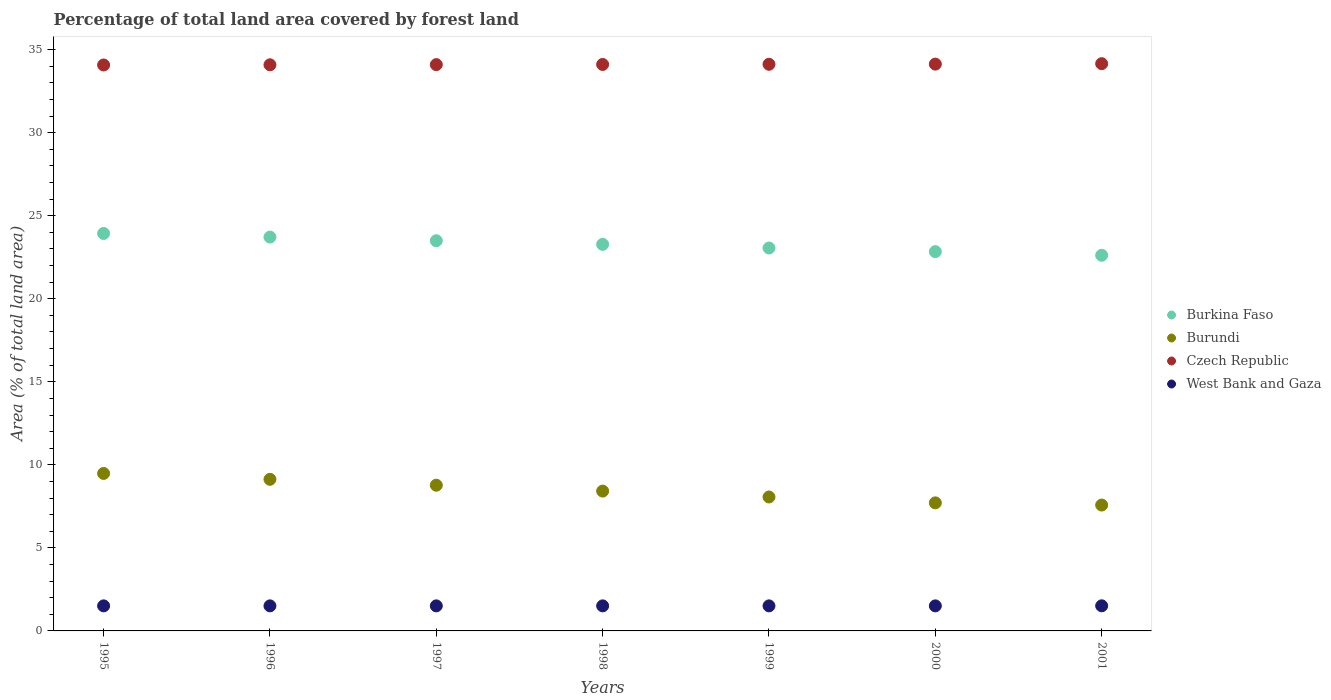How many different coloured dotlines are there?
Ensure brevity in your answer.  4. What is the percentage of forest land in Burundi in 1995?
Keep it short and to the point. 9.48. Across all years, what is the maximum percentage of forest land in Czech Republic?
Make the answer very short. 34.15. Across all years, what is the minimum percentage of forest land in West Bank and Gaza?
Provide a succinct answer. 1.51. In which year was the percentage of forest land in Burkina Faso maximum?
Your response must be concise. 1995. In which year was the percentage of forest land in Burundi minimum?
Keep it short and to the point. 2001. What is the total percentage of forest land in West Bank and Gaza in the graph?
Make the answer very short. 10.56. What is the difference between the percentage of forest land in Burundi in 1998 and that in 2001?
Provide a short and direct response. 0.84. What is the difference between the percentage of forest land in Burundi in 1997 and the percentage of forest land in Czech Republic in 1996?
Offer a terse response. -25.31. What is the average percentage of forest land in Burundi per year?
Offer a very short reply. 8.45. In the year 2000, what is the difference between the percentage of forest land in Burkina Faso and percentage of forest land in Czech Republic?
Keep it short and to the point. -11.29. What is the ratio of the percentage of forest land in Burkina Faso in 1999 to that in 2000?
Provide a short and direct response. 1.01. What is the difference between the highest and the second highest percentage of forest land in Burundi?
Offer a very short reply. 0.35. What is the difference between the highest and the lowest percentage of forest land in Burundi?
Keep it short and to the point. 1.9. Is the percentage of forest land in Burundi strictly greater than the percentage of forest land in Czech Republic over the years?
Give a very brief answer. No. Is the percentage of forest land in Burkina Faso strictly less than the percentage of forest land in West Bank and Gaza over the years?
Your answer should be very brief. No. How many dotlines are there?
Your answer should be compact. 4. How many years are there in the graph?
Provide a short and direct response. 7. Where does the legend appear in the graph?
Provide a succinct answer. Center right. How are the legend labels stacked?
Offer a terse response. Vertical. What is the title of the graph?
Provide a short and direct response. Percentage of total land area covered by forest land. What is the label or title of the X-axis?
Your answer should be compact. Years. What is the label or title of the Y-axis?
Your answer should be compact. Area (% of total land area). What is the Area (% of total land area) in Burkina Faso in 1995?
Give a very brief answer. 23.93. What is the Area (% of total land area) of Burundi in 1995?
Provide a succinct answer. 9.48. What is the Area (% of total land area) in Czech Republic in 1995?
Provide a short and direct response. 34.08. What is the Area (% of total land area) of West Bank and Gaza in 1995?
Offer a very short reply. 1.51. What is the Area (% of total land area) in Burkina Faso in 1996?
Keep it short and to the point. 23.71. What is the Area (% of total land area) of Burundi in 1996?
Your response must be concise. 9.13. What is the Area (% of total land area) of Czech Republic in 1996?
Offer a very short reply. 34.09. What is the Area (% of total land area) in West Bank and Gaza in 1996?
Make the answer very short. 1.51. What is the Area (% of total land area) of Burkina Faso in 1997?
Ensure brevity in your answer.  23.49. What is the Area (% of total land area) of Burundi in 1997?
Your answer should be compact. 8.77. What is the Area (% of total land area) of Czech Republic in 1997?
Give a very brief answer. 34.1. What is the Area (% of total land area) of West Bank and Gaza in 1997?
Provide a succinct answer. 1.51. What is the Area (% of total land area) in Burkina Faso in 1998?
Your answer should be very brief. 23.27. What is the Area (% of total land area) in Burundi in 1998?
Offer a terse response. 8.42. What is the Area (% of total land area) of Czech Republic in 1998?
Keep it short and to the point. 34.11. What is the Area (% of total land area) in West Bank and Gaza in 1998?
Your answer should be very brief. 1.51. What is the Area (% of total land area) of Burkina Faso in 1999?
Your response must be concise. 23.06. What is the Area (% of total land area) of Burundi in 1999?
Give a very brief answer. 8.06. What is the Area (% of total land area) of Czech Republic in 1999?
Offer a very short reply. 34.12. What is the Area (% of total land area) in West Bank and Gaza in 1999?
Your response must be concise. 1.51. What is the Area (% of total land area) in Burkina Faso in 2000?
Your answer should be compact. 22.84. What is the Area (% of total land area) in Burundi in 2000?
Your response must be concise. 7.71. What is the Area (% of total land area) in Czech Republic in 2000?
Keep it short and to the point. 34.13. What is the Area (% of total land area) of West Bank and Gaza in 2000?
Give a very brief answer. 1.51. What is the Area (% of total land area) of Burkina Faso in 2001?
Give a very brief answer. 22.62. What is the Area (% of total land area) in Burundi in 2001?
Offer a terse response. 7.58. What is the Area (% of total land area) of Czech Republic in 2001?
Your answer should be compact. 34.15. What is the Area (% of total land area) of West Bank and Gaza in 2001?
Give a very brief answer. 1.51. Across all years, what is the maximum Area (% of total land area) of Burkina Faso?
Make the answer very short. 23.93. Across all years, what is the maximum Area (% of total land area) of Burundi?
Your response must be concise. 9.48. Across all years, what is the maximum Area (% of total land area) of Czech Republic?
Give a very brief answer. 34.15. Across all years, what is the maximum Area (% of total land area) in West Bank and Gaza?
Your response must be concise. 1.51. Across all years, what is the minimum Area (% of total land area) of Burkina Faso?
Offer a terse response. 22.62. Across all years, what is the minimum Area (% of total land area) in Burundi?
Provide a succinct answer. 7.58. Across all years, what is the minimum Area (% of total land area) in Czech Republic?
Ensure brevity in your answer.  34.08. Across all years, what is the minimum Area (% of total land area) in West Bank and Gaza?
Offer a terse response. 1.51. What is the total Area (% of total land area) of Burkina Faso in the graph?
Offer a very short reply. 162.92. What is the total Area (% of total land area) in Burundi in the graph?
Make the answer very short. 59.16. What is the total Area (% of total land area) of Czech Republic in the graph?
Offer a very short reply. 238.76. What is the total Area (% of total land area) of West Bank and Gaza in the graph?
Offer a very short reply. 10.56. What is the difference between the Area (% of total land area) in Burkina Faso in 1995 and that in 1996?
Your response must be concise. 0.22. What is the difference between the Area (% of total land area) in Burundi in 1995 and that in 1996?
Give a very brief answer. 0.35. What is the difference between the Area (% of total land area) of Czech Republic in 1995 and that in 1996?
Make the answer very short. -0.01. What is the difference between the Area (% of total land area) of Burkina Faso in 1995 and that in 1997?
Offer a very short reply. 0.44. What is the difference between the Area (% of total land area) in Burundi in 1995 and that in 1997?
Your response must be concise. 0.71. What is the difference between the Area (% of total land area) in Czech Republic in 1995 and that in 1997?
Your answer should be compact. -0.02. What is the difference between the Area (% of total land area) of Burkina Faso in 1995 and that in 1998?
Provide a short and direct response. 0.66. What is the difference between the Area (% of total land area) of Burundi in 1995 and that in 1998?
Your answer should be compact. 1.06. What is the difference between the Area (% of total land area) in Czech Republic in 1995 and that in 1998?
Keep it short and to the point. -0.03. What is the difference between the Area (% of total land area) in Burkina Faso in 1995 and that in 1999?
Offer a very short reply. 0.88. What is the difference between the Area (% of total land area) of Burundi in 1995 and that in 1999?
Offer a very short reply. 1.42. What is the difference between the Area (% of total land area) in Czech Republic in 1995 and that in 1999?
Offer a very short reply. -0.04. What is the difference between the Area (% of total land area) in West Bank and Gaza in 1995 and that in 1999?
Your answer should be very brief. 0. What is the difference between the Area (% of total land area) of Burkina Faso in 1995 and that in 2000?
Offer a very short reply. 1.09. What is the difference between the Area (% of total land area) of Burundi in 1995 and that in 2000?
Give a very brief answer. 1.77. What is the difference between the Area (% of total land area) of Czech Republic in 1995 and that in 2000?
Offer a very short reply. -0.05. What is the difference between the Area (% of total land area) in West Bank and Gaza in 1995 and that in 2000?
Offer a terse response. 0. What is the difference between the Area (% of total land area) of Burkina Faso in 1995 and that in 2001?
Offer a very short reply. 1.31. What is the difference between the Area (% of total land area) in Burundi in 1995 and that in 2001?
Ensure brevity in your answer.  1.9. What is the difference between the Area (% of total land area) of Czech Republic in 1995 and that in 2001?
Your answer should be very brief. -0.08. What is the difference between the Area (% of total land area) in West Bank and Gaza in 1995 and that in 2001?
Keep it short and to the point. -0. What is the difference between the Area (% of total land area) in Burkina Faso in 1996 and that in 1997?
Your answer should be very brief. 0.22. What is the difference between the Area (% of total land area) of Burundi in 1996 and that in 1997?
Provide a short and direct response. 0.35. What is the difference between the Area (% of total land area) in Czech Republic in 1996 and that in 1997?
Make the answer very short. -0.01. What is the difference between the Area (% of total land area) in Burkina Faso in 1996 and that in 1998?
Offer a very short reply. 0.44. What is the difference between the Area (% of total land area) in Burundi in 1996 and that in 1998?
Provide a short and direct response. 0.71. What is the difference between the Area (% of total land area) of Czech Republic in 1996 and that in 1998?
Your answer should be very brief. -0.02. What is the difference between the Area (% of total land area) of West Bank and Gaza in 1996 and that in 1998?
Provide a short and direct response. 0. What is the difference between the Area (% of total land area) in Burkina Faso in 1996 and that in 1999?
Offer a terse response. 0.66. What is the difference between the Area (% of total land area) of Burundi in 1996 and that in 1999?
Offer a terse response. 1.06. What is the difference between the Area (% of total land area) in Czech Republic in 1996 and that in 1999?
Give a very brief answer. -0.03. What is the difference between the Area (% of total land area) in Burkina Faso in 1996 and that in 2000?
Make the answer very short. 0.88. What is the difference between the Area (% of total land area) in Burundi in 1996 and that in 2000?
Your answer should be very brief. 1.42. What is the difference between the Area (% of total land area) of Czech Republic in 1996 and that in 2000?
Make the answer very short. -0.04. What is the difference between the Area (% of total land area) of West Bank and Gaza in 1996 and that in 2000?
Your answer should be very brief. 0. What is the difference between the Area (% of total land area) of Burkina Faso in 1996 and that in 2001?
Offer a very short reply. 1.09. What is the difference between the Area (% of total land area) in Burundi in 1996 and that in 2001?
Provide a succinct answer. 1.55. What is the difference between the Area (% of total land area) in Czech Republic in 1996 and that in 2001?
Your answer should be compact. -0.07. What is the difference between the Area (% of total land area) in West Bank and Gaza in 1996 and that in 2001?
Your answer should be very brief. -0. What is the difference between the Area (% of total land area) in Burkina Faso in 1997 and that in 1998?
Make the answer very short. 0.22. What is the difference between the Area (% of total land area) in Burundi in 1997 and that in 1998?
Ensure brevity in your answer.  0.35. What is the difference between the Area (% of total land area) of Czech Republic in 1997 and that in 1998?
Offer a very short reply. -0.01. What is the difference between the Area (% of total land area) in Burkina Faso in 1997 and that in 1999?
Your answer should be compact. 0.44. What is the difference between the Area (% of total land area) in Burundi in 1997 and that in 1999?
Keep it short and to the point. 0.71. What is the difference between the Area (% of total land area) of Czech Republic in 1997 and that in 1999?
Offer a terse response. -0.02. What is the difference between the Area (% of total land area) of Burkina Faso in 1997 and that in 2000?
Your response must be concise. 0.66. What is the difference between the Area (% of total land area) in Burundi in 1997 and that in 2000?
Make the answer very short. 1.06. What is the difference between the Area (% of total land area) in Czech Republic in 1997 and that in 2000?
Your answer should be very brief. -0.03. What is the difference between the Area (% of total land area) in West Bank and Gaza in 1997 and that in 2000?
Offer a very short reply. 0. What is the difference between the Area (% of total land area) in Burkina Faso in 1997 and that in 2001?
Ensure brevity in your answer.  0.88. What is the difference between the Area (% of total land area) in Burundi in 1997 and that in 2001?
Your answer should be very brief. 1.2. What is the difference between the Area (% of total land area) in Czech Republic in 1997 and that in 2001?
Ensure brevity in your answer.  -0.06. What is the difference between the Area (% of total land area) of West Bank and Gaza in 1997 and that in 2001?
Your response must be concise. -0. What is the difference between the Area (% of total land area) of Burkina Faso in 1998 and that in 1999?
Ensure brevity in your answer.  0.22. What is the difference between the Area (% of total land area) of Burundi in 1998 and that in 1999?
Make the answer very short. 0.35. What is the difference between the Area (% of total land area) in Czech Republic in 1998 and that in 1999?
Offer a very short reply. -0.01. What is the difference between the Area (% of total land area) in West Bank and Gaza in 1998 and that in 1999?
Provide a short and direct response. 0. What is the difference between the Area (% of total land area) of Burkina Faso in 1998 and that in 2000?
Make the answer very short. 0.44. What is the difference between the Area (% of total land area) in Burundi in 1998 and that in 2000?
Offer a terse response. 0.71. What is the difference between the Area (% of total land area) in Czech Republic in 1998 and that in 2000?
Give a very brief answer. -0.02. What is the difference between the Area (% of total land area) in West Bank and Gaza in 1998 and that in 2000?
Provide a short and direct response. 0. What is the difference between the Area (% of total land area) in Burkina Faso in 1998 and that in 2001?
Keep it short and to the point. 0.66. What is the difference between the Area (% of total land area) of Burundi in 1998 and that in 2001?
Your response must be concise. 0.84. What is the difference between the Area (% of total land area) in Czech Republic in 1998 and that in 2001?
Offer a terse response. -0.05. What is the difference between the Area (% of total land area) of West Bank and Gaza in 1998 and that in 2001?
Provide a short and direct response. -0. What is the difference between the Area (% of total land area) in Burkina Faso in 1999 and that in 2000?
Provide a short and direct response. 0.22. What is the difference between the Area (% of total land area) of Burundi in 1999 and that in 2000?
Keep it short and to the point. 0.35. What is the difference between the Area (% of total land area) in Czech Republic in 1999 and that in 2000?
Your response must be concise. -0.01. What is the difference between the Area (% of total land area) in West Bank and Gaza in 1999 and that in 2000?
Give a very brief answer. 0. What is the difference between the Area (% of total land area) of Burkina Faso in 1999 and that in 2001?
Ensure brevity in your answer.  0.44. What is the difference between the Area (% of total land area) of Burundi in 1999 and that in 2001?
Keep it short and to the point. 0.49. What is the difference between the Area (% of total land area) in Czech Republic in 1999 and that in 2001?
Offer a terse response. -0.04. What is the difference between the Area (% of total land area) in West Bank and Gaza in 1999 and that in 2001?
Ensure brevity in your answer.  -0. What is the difference between the Area (% of total land area) in Burkina Faso in 2000 and that in 2001?
Provide a succinct answer. 0.22. What is the difference between the Area (% of total land area) in Burundi in 2000 and that in 2001?
Make the answer very short. 0.13. What is the difference between the Area (% of total land area) of Czech Republic in 2000 and that in 2001?
Keep it short and to the point. -0.03. What is the difference between the Area (% of total land area) of West Bank and Gaza in 2000 and that in 2001?
Offer a very short reply. -0. What is the difference between the Area (% of total land area) of Burkina Faso in 1995 and the Area (% of total land area) of Burundi in 1996?
Your answer should be very brief. 14.8. What is the difference between the Area (% of total land area) in Burkina Faso in 1995 and the Area (% of total land area) in Czech Republic in 1996?
Provide a succinct answer. -10.15. What is the difference between the Area (% of total land area) in Burkina Faso in 1995 and the Area (% of total land area) in West Bank and Gaza in 1996?
Offer a terse response. 22.42. What is the difference between the Area (% of total land area) in Burundi in 1995 and the Area (% of total land area) in Czech Republic in 1996?
Offer a very short reply. -24.6. What is the difference between the Area (% of total land area) in Burundi in 1995 and the Area (% of total land area) in West Bank and Gaza in 1996?
Your answer should be very brief. 7.97. What is the difference between the Area (% of total land area) in Czech Republic in 1995 and the Area (% of total land area) in West Bank and Gaza in 1996?
Ensure brevity in your answer.  32.57. What is the difference between the Area (% of total land area) of Burkina Faso in 1995 and the Area (% of total land area) of Burundi in 1997?
Keep it short and to the point. 15.16. What is the difference between the Area (% of total land area) of Burkina Faso in 1995 and the Area (% of total land area) of Czech Republic in 1997?
Ensure brevity in your answer.  -10.17. What is the difference between the Area (% of total land area) in Burkina Faso in 1995 and the Area (% of total land area) in West Bank and Gaza in 1997?
Give a very brief answer. 22.42. What is the difference between the Area (% of total land area) of Burundi in 1995 and the Area (% of total land area) of Czech Republic in 1997?
Make the answer very short. -24.61. What is the difference between the Area (% of total land area) in Burundi in 1995 and the Area (% of total land area) in West Bank and Gaza in 1997?
Provide a short and direct response. 7.97. What is the difference between the Area (% of total land area) of Czech Republic in 1995 and the Area (% of total land area) of West Bank and Gaza in 1997?
Offer a very short reply. 32.57. What is the difference between the Area (% of total land area) of Burkina Faso in 1995 and the Area (% of total land area) of Burundi in 1998?
Your answer should be very brief. 15.51. What is the difference between the Area (% of total land area) of Burkina Faso in 1995 and the Area (% of total land area) of Czech Republic in 1998?
Give a very brief answer. -10.18. What is the difference between the Area (% of total land area) of Burkina Faso in 1995 and the Area (% of total land area) of West Bank and Gaza in 1998?
Your answer should be very brief. 22.42. What is the difference between the Area (% of total land area) of Burundi in 1995 and the Area (% of total land area) of Czech Republic in 1998?
Offer a terse response. -24.62. What is the difference between the Area (% of total land area) in Burundi in 1995 and the Area (% of total land area) in West Bank and Gaza in 1998?
Provide a succinct answer. 7.97. What is the difference between the Area (% of total land area) in Czech Republic in 1995 and the Area (% of total land area) in West Bank and Gaza in 1998?
Give a very brief answer. 32.57. What is the difference between the Area (% of total land area) of Burkina Faso in 1995 and the Area (% of total land area) of Burundi in 1999?
Keep it short and to the point. 15.87. What is the difference between the Area (% of total land area) of Burkina Faso in 1995 and the Area (% of total land area) of Czech Republic in 1999?
Give a very brief answer. -10.19. What is the difference between the Area (% of total land area) in Burkina Faso in 1995 and the Area (% of total land area) in West Bank and Gaza in 1999?
Keep it short and to the point. 22.42. What is the difference between the Area (% of total land area) in Burundi in 1995 and the Area (% of total land area) in Czech Republic in 1999?
Keep it short and to the point. -24.63. What is the difference between the Area (% of total land area) in Burundi in 1995 and the Area (% of total land area) in West Bank and Gaza in 1999?
Make the answer very short. 7.97. What is the difference between the Area (% of total land area) in Czech Republic in 1995 and the Area (% of total land area) in West Bank and Gaza in 1999?
Your answer should be compact. 32.57. What is the difference between the Area (% of total land area) in Burkina Faso in 1995 and the Area (% of total land area) in Burundi in 2000?
Keep it short and to the point. 16.22. What is the difference between the Area (% of total land area) of Burkina Faso in 1995 and the Area (% of total land area) of Czech Republic in 2000?
Keep it short and to the point. -10.2. What is the difference between the Area (% of total land area) of Burkina Faso in 1995 and the Area (% of total land area) of West Bank and Gaza in 2000?
Your response must be concise. 22.42. What is the difference between the Area (% of total land area) in Burundi in 1995 and the Area (% of total land area) in Czech Republic in 2000?
Keep it short and to the point. -24.64. What is the difference between the Area (% of total land area) in Burundi in 1995 and the Area (% of total land area) in West Bank and Gaza in 2000?
Offer a terse response. 7.97. What is the difference between the Area (% of total land area) in Czech Republic in 1995 and the Area (% of total land area) in West Bank and Gaza in 2000?
Offer a terse response. 32.57. What is the difference between the Area (% of total land area) in Burkina Faso in 1995 and the Area (% of total land area) in Burundi in 2001?
Your response must be concise. 16.35. What is the difference between the Area (% of total land area) of Burkina Faso in 1995 and the Area (% of total land area) of Czech Republic in 2001?
Give a very brief answer. -10.22. What is the difference between the Area (% of total land area) of Burkina Faso in 1995 and the Area (% of total land area) of West Bank and Gaza in 2001?
Your answer should be very brief. 22.42. What is the difference between the Area (% of total land area) of Burundi in 1995 and the Area (% of total land area) of Czech Republic in 2001?
Provide a succinct answer. -24.67. What is the difference between the Area (% of total land area) in Burundi in 1995 and the Area (% of total land area) in West Bank and Gaza in 2001?
Your response must be concise. 7.97. What is the difference between the Area (% of total land area) of Czech Republic in 1995 and the Area (% of total land area) of West Bank and Gaza in 2001?
Offer a terse response. 32.56. What is the difference between the Area (% of total land area) in Burkina Faso in 1996 and the Area (% of total land area) in Burundi in 1997?
Offer a very short reply. 14.94. What is the difference between the Area (% of total land area) of Burkina Faso in 1996 and the Area (% of total land area) of Czech Republic in 1997?
Give a very brief answer. -10.38. What is the difference between the Area (% of total land area) in Burkina Faso in 1996 and the Area (% of total land area) in West Bank and Gaza in 1997?
Provide a short and direct response. 22.2. What is the difference between the Area (% of total land area) in Burundi in 1996 and the Area (% of total land area) in Czech Republic in 1997?
Provide a succinct answer. -24.97. What is the difference between the Area (% of total land area) in Burundi in 1996 and the Area (% of total land area) in West Bank and Gaza in 1997?
Give a very brief answer. 7.62. What is the difference between the Area (% of total land area) in Czech Republic in 1996 and the Area (% of total land area) in West Bank and Gaza in 1997?
Provide a short and direct response. 32.58. What is the difference between the Area (% of total land area) in Burkina Faso in 1996 and the Area (% of total land area) in Burundi in 1998?
Your answer should be very brief. 15.29. What is the difference between the Area (% of total land area) in Burkina Faso in 1996 and the Area (% of total land area) in Czech Republic in 1998?
Offer a terse response. -10.39. What is the difference between the Area (% of total land area) of Burkina Faso in 1996 and the Area (% of total land area) of West Bank and Gaza in 1998?
Give a very brief answer. 22.2. What is the difference between the Area (% of total land area) in Burundi in 1996 and the Area (% of total land area) in Czech Republic in 1998?
Ensure brevity in your answer.  -24.98. What is the difference between the Area (% of total land area) of Burundi in 1996 and the Area (% of total land area) of West Bank and Gaza in 1998?
Give a very brief answer. 7.62. What is the difference between the Area (% of total land area) of Czech Republic in 1996 and the Area (% of total land area) of West Bank and Gaza in 1998?
Provide a short and direct response. 32.58. What is the difference between the Area (% of total land area) of Burkina Faso in 1996 and the Area (% of total land area) of Burundi in 1999?
Offer a very short reply. 15.65. What is the difference between the Area (% of total land area) in Burkina Faso in 1996 and the Area (% of total land area) in Czech Republic in 1999?
Offer a very short reply. -10.4. What is the difference between the Area (% of total land area) of Burkina Faso in 1996 and the Area (% of total land area) of West Bank and Gaza in 1999?
Offer a terse response. 22.2. What is the difference between the Area (% of total land area) in Burundi in 1996 and the Area (% of total land area) in Czech Republic in 1999?
Keep it short and to the point. -24.99. What is the difference between the Area (% of total land area) of Burundi in 1996 and the Area (% of total land area) of West Bank and Gaza in 1999?
Provide a succinct answer. 7.62. What is the difference between the Area (% of total land area) in Czech Republic in 1996 and the Area (% of total land area) in West Bank and Gaza in 1999?
Keep it short and to the point. 32.58. What is the difference between the Area (% of total land area) in Burkina Faso in 1996 and the Area (% of total land area) in Burundi in 2000?
Provide a succinct answer. 16. What is the difference between the Area (% of total land area) in Burkina Faso in 1996 and the Area (% of total land area) in Czech Republic in 2000?
Provide a succinct answer. -10.42. What is the difference between the Area (% of total land area) in Burkina Faso in 1996 and the Area (% of total land area) in West Bank and Gaza in 2000?
Your answer should be very brief. 22.2. What is the difference between the Area (% of total land area) in Burundi in 1996 and the Area (% of total land area) in Czech Republic in 2000?
Offer a very short reply. -25. What is the difference between the Area (% of total land area) of Burundi in 1996 and the Area (% of total land area) of West Bank and Gaza in 2000?
Keep it short and to the point. 7.62. What is the difference between the Area (% of total land area) in Czech Republic in 1996 and the Area (% of total land area) in West Bank and Gaza in 2000?
Provide a short and direct response. 32.58. What is the difference between the Area (% of total land area) in Burkina Faso in 1996 and the Area (% of total land area) in Burundi in 2001?
Offer a terse response. 16.13. What is the difference between the Area (% of total land area) of Burkina Faso in 1996 and the Area (% of total land area) of Czech Republic in 2001?
Give a very brief answer. -10.44. What is the difference between the Area (% of total land area) of Burkina Faso in 1996 and the Area (% of total land area) of West Bank and Gaza in 2001?
Your answer should be compact. 22.2. What is the difference between the Area (% of total land area) of Burundi in 1996 and the Area (% of total land area) of Czech Republic in 2001?
Offer a terse response. -25.03. What is the difference between the Area (% of total land area) in Burundi in 1996 and the Area (% of total land area) in West Bank and Gaza in 2001?
Give a very brief answer. 7.62. What is the difference between the Area (% of total land area) of Czech Republic in 1996 and the Area (% of total land area) of West Bank and Gaza in 2001?
Ensure brevity in your answer.  32.57. What is the difference between the Area (% of total land area) in Burkina Faso in 1997 and the Area (% of total land area) in Burundi in 1998?
Ensure brevity in your answer.  15.07. What is the difference between the Area (% of total land area) of Burkina Faso in 1997 and the Area (% of total land area) of Czech Republic in 1998?
Your response must be concise. -10.61. What is the difference between the Area (% of total land area) of Burkina Faso in 1997 and the Area (% of total land area) of West Bank and Gaza in 1998?
Offer a very short reply. 21.98. What is the difference between the Area (% of total land area) of Burundi in 1997 and the Area (% of total land area) of Czech Republic in 1998?
Offer a terse response. -25.33. What is the difference between the Area (% of total land area) in Burundi in 1997 and the Area (% of total land area) in West Bank and Gaza in 1998?
Give a very brief answer. 7.27. What is the difference between the Area (% of total land area) in Czech Republic in 1997 and the Area (% of total land area) in West Bank and Gaza in 1998?
Keep it short and to the point. 32.59. What is the difference between the Area (% of total land area) of Burkina Faso in 1997 and the Area (% of total land area) of Burundi in 1999?
Ensure brevity in your answer.  15.43. What is the difference between the Area (% of total land area) in Burkina Faso in 1997 and the Area (% of total land area) in Czech Republic in 1999?
Keep it short and to the point. -10.62. What is the difference between the Area (% of total land area) in Burkina Faso in 1997 and the Area (% of total land area) in West Bank and Gaza in 1999?
Provide a succinct answer. 21.98. What is the difference between the Area (% of total land area) of Burundi in 1997 and the Area (% of total land area) of Czech Republic in 1999?
Keep it short and to the point. -25.34. What is the difference between the Area (% of total land area) in Burundi in 1997 and the Area (% of total land area) in West Bank and Gaza in 1999?
Provide a short and direct response. 7.27. What is the difference between the Area (% of total land area) in Czech Republic in 1997 and the Area (% of total land area) in West Bank and Gaza in 1999?
Ensure brevity in your answer.  32.59. What is the difference between the Area (% of total land area) of Burkina Faso in 1997 and the Area (% of total land area) of Burundi in 2000?
Your response must be concise. 15.78. What is the difference between the Area (% of total land area) of Burkina Faso in 1997 and the Area (% of total land area) of Czech Republic in 2000?
Your answer should be compact. -10.63. What is the difference between the Area (% of total land area) in Burkina Faso in 1997 and the Area (% of total land area) in West Bank and Gaza in 2000?
Offer a very short reply. 21.98. What is the difference between the Area (% of total land area) in Burundi in 1997 and the Area (% of total land area) in Czech Republic in 2000?
Offer a terse response. -25.35. What is the difference between the Area (% of total land area) in Burundi in 1997 and the Area (% of total land area) in West Bank and Gaza in 2000?
Give a very brief answer. 7.27. What is the difference between the Area (% of total land area) of Czech Republic in 1997 and the Area (% of total land area) of West Bank and Gaza in 2000?
Provide a short and direct response. 32.59. What is the difference between the Area (% of total land area) of Burkina Faso in 1997 and the Area (% of total land area) of Burundi in 2001?
Keep it short and to the point. 15.92. What is the difference between the Area (% of total land area) in Burkina Faso in 1997 and the Area (% of total land area) in Czech Republic in 2001?
Your answer should be very brief. -10.66. What is the difference between the Area (% of total land area) in Burkina Faso in 1997 and the Area (% of total land area) in West Bank and Gaza in 2001?
Your answer should be compact. 21.98. What is the difference between the Area (% of total land area) in Burundi in 1997 and the Area (% of total land area) in Czech Republic in 2001?
Your answer should be compact. -25.38. What is the difference between the Area (% of total land area) in Burundi in 1997 and the Area (% of total land area) in West Bank and Gaza in 2001?
Your answer should be compact. 7.26. What is the difference between the Area (% of total land area) of Czech Republic in 1997 and the Area (% of total land area) of West Bank and Gaza in 2001?
Your response must be concise. 32.58. What is the difference between the Area (% of total land area) of Burkina Faso in 1998 and the Area (% of total land area) of Burundi in 1999?
Ensure brevity in your answer.  15.21. What is the difference between the Area (% of total land area) of Burkina Faso in 1998 and the Area (% of total land area) of Czech Republic in 1999?
Give a very brief answer. -10.84. What is the difference between the Area (% of total land area) of Burkina Faso in 1998 and the Area (% of total land area) of West Bank and Gaza in 1999?
Offer a terse response. 21.77. What is the difference between the Area (% of total land area) in Burundi in 1998 and the Area (% of total land area) in Czech Republic in 1999?
Offer a terse response. -25.7. What is the difference between the Area (% of total land area) of Burundi in 1998 and the Area (% of total land area) of West Bank and Gaza in 1999?
Offer a very short reply. 6.91. What is the difference between the Area (% of total land area) in Czech Republic in 1998 and the Area (% of total land area) in West Bank and Gaza in 1999?
Provide a short and direct response. 32.6. What is the difference between the Area (% of total land area) in Burkina Faso in 1998 and the Area (% of total land area) in Burundi in 2000?
Your answer should be compact. 15.56. What is the difference between the Area (% of total land area) of Burkina Faso in 1998 and the Area (% of total land area) of Czech Republic in 2000?
Give a very brief answer. -10.85. What is the difference between the Area (% of total land area) in Burkina Faso in 1998 and the Area (% of total land area) in West Bank and Gaza in 2000?
Provide a succinct answer. 21.77. What is the difference between the Area (% of total land area) in Burundi in 1998 and the Area (% of total land area) in Czech Republic in 2000?
Your answer should be very brief. -25.71. What is the difference between the Area (% of total land area) in Burundi in 1998 and the Area (% of total land area) in West Bank and Gaza in 2000?
Your answer should be compact. 6.91. What is the difference between the Area (% of total land area) of Czech Republic in 1998 and the Area (% of total land area) of West Bank and Gaza in 2000?
Provide a short and direct response. 32.6. What is the difference between the Area (% of total land area) in Burkina Faso in 1998 and the Area (% of total land area) in Burundi in 2001?
Keep it short and to the point. 15.7. What is the difference between the Area (% of total land area) in Burkina Faso in 1998 and the Area (% of total land area) in Czech Republic in 2001?
Give a very brief answer. -10.88. What is the difference between the Area (% of total land area) of Burkina Faso in 1998 and the Area (% of total land area) of West Bank and Gaza in 2001?
Give a very brief answer. 21.76. What is the difference between the Area (% of total land area) of Burundi in 1998 and the Area (% of total land area) of Czech Republic in 2001?
Offer a very short reply. -25.73. What is the difference between the Area (% of total land area) of Burundi in 1998 and the Area (% of total land area) of West Bank and Gaza in 2001?
Offer a very short reply. 6.91. What is the difference between the Area (% of total land area) in Czech Republic in 1998 and the Area (% of total land area) in West Bank and Gaza in 2001?
Your answer should be compact. 32.59. What is the difference between the Area (% of total land area) in Burkina Faso in 1999 and the Area (% of total land area) in Burundi in 2000?
Your response must be concise. 15.34. What is the difference between the Area (% of total land area) of Burkina Faso in 1999 and the Area (% of total land area) of Czech Republic in 2000?
Make the answer very short. -11.07. What is the difference between the Area (% of total land area) in Burkina Faso in 1999 and the Area (% of total land area) in West Bank and Gaza in 2000?
Offer a very short reply. 21.55. What is the difference between the Area (% of total land area) in Burundi in 1999 and the Area (% of total land area) in Czech Republic in 2000?
Keep it short and to the point. -26.06. What is the difference between the Area (% of total land area) in Burundi in 1999 and the Area (% of total land area) in West Bank and Gaza in 2000?
Make the answer very short. 6.56. What is the difference between the Area (% of total land area) of Czech Republic in 1999 and the Area (% of total land area) of West Bank and Gaza in 2000?
Make the answer very short. 32.61. What is the difference between the Area (% of total land area) in Burkina Faso in 1999 and the Area (% of total land area) in Burundi in 2001?
Keep it short and to the point. 15.48. What is the difference between the Area (% of total land area) of Burkina Faso in 1999 and the Area (% of total land area) of Czech Republic in 2001?
Offer a very short reply. -11.1. What is the difference between the Area (% of total land area) of Burkina Faso in 1999 and the Area (% of total land area) of West Bank and Gaza in 2001?
Your answer should be very brief. 21.54. What is the difference between the Area (% of total land area) of Burundi in 1999 and the Area (% of total land area) of Czech Republic in 2001?
Provide a succinct answer. -26.09. What is the difference between the Area (% of total land area) of Burundi in 1999 and the Area (% of total land area) of West Bank and Gaza in 2001?
Your response must be concise. 6.55. What is the difference between the Area (% of total land area) in Czech Republic in 1999 and the Area (% of total land area) in West Bank and Gaza in 2001?
Ensure brevity in your answer.  32.61. What is the difference between the Area (% of total land area) of Burkina Faso in 2000 and the Area (% of total land area) of Burundi in 2001?
Offer a very short reply. 15.26. What is the difference between the Area (% of total land area) of Burkina Faso in 2000 and the Area (% of total land area) of Czech Republic in 2001?
Your answer should be very brief. -11.32. What is the difference between the Area (% of total land area) in Burkina Faso in 2000 and the Area (% of total land area) in West Bank and Gaza in 2001?
Give a very brief answer. 21.32. What is the difference between the Area (% of total land area) of Burundi in 2000 and the Area (% of total land area) of Czech Republic in 2001?
Your answer should be very brief. -26.44. What is the difference between the Area (% of total land area) in Burundi in 2000 and the Area (% of total land area) in West Bank and Gaza in 2001?
Your answer should be compact. 6.2. What is the difference between the Area (% of total land area) of Czech Republic in 2000 and the Area (% of total land area) of West Bank and Gaza in 2001?
Your answer should be very brief. 32.62. What is the average Area (% of total land area) in Burkina Faso per year?
Ensure brevity in your answer.  23.27. What is the average Area (% of total land area) in Burundi per year?
Your answer should be very brief. 8.45. What is the average Area (% of total land area) in Czech Republic per year?
Make the answer very short. 34.11. What is the average Area (% of total land area) in West Bank and Gaza per year?
Provide a succinct answer. 1.51. In the year 1995, what is the difference between the Area (% of total land area) in Burkina Faso and Area (% of total land area) in Burundi?
Offer a very short reply. 14.45. In the year 1995, what is the difference between the Area (% of total land area) of Burkina Faso and Area (% of total land area) of Czech Republic?
Your answer should be very brief. -10.14. In the year 1995, what is the difference between the Area (% of total land area) of Burkina Faso and Area (% of total land area) of West Bank and Gaza?
Provide a succinct answer. 22.42. In the year 1995, what is the difference between the Area (% of total land area) of Burundi and Area (% of total land area) of Czech Republic?
Your answer should be compact. -24.59. In the year 1995, what is the difference between the Area (% of total land area) of Burundi and Area (% of total land area) of West Bank and Gaza?
Keep it short and to the point. 7.97. In the year 1995, what is the difference between the Area (% of total land area) in Czech Republic and Area (% of total land area) in West Bank and Gaza?
Ensure brevity in your answer.  32.57. In the year 1996, what is the difference between the Area (% of total land area) of Burkina Faso and Area (% of total land area) of Burundi?
Your response must be concise. 14.58. In the year 1996, what is the difference between the Area (% of total land area) of Burkina Faso and Area (% of total land area) of Czech Republic?
Give a very brief answer. -10.37. In the year 1996, what is the difference between the Area (% of total land area) in Burkina Faso and Area (% of total land area) in West Bank and Gaza?
Give a very brief answer. 22.2. In the year 1996, what is the difference between the Area (% of total land area) of Burundi and Area (% of total land area) of Czech Republic?
Give a very brief answer. -24.96. In the year 1996, what is the difference between the Area (% of total land area) of Burundi and Area (% of total land area) of West Bank and Gaza?
Provide a succinct answer. 7.62. In the year 1996, what is the difference between the Area (% of total land area) of Czech Republic and Area (% of total land area) of West Bank and Gaza?
Offer a terse response. 32.58. In the year 1997, what is the difference between the Area (% of total land area) of Burkina Faso and Area (% of total land area) of Burundi?
Provide a short and direct response. 14.72. In the year 1997, what is the difference between the Area (% of total land area) of Burkina Faso and Area (% of total land area) of Czech Republic?
Your response must be concise. -10.6. In the year 1997, what is the difference between the Area (% of total land area) of Burkina Faso and Area (% of total land area) of West Bank and Gaza?
Ensure brevity in your answer.  21.98. In the year 1997, what is the difference between the Area (% of total land area) in Burundi and Area (% of total land area) in Czech Republic?
Provide a succinct answer. -25.32. In the year 1997, what is the difference between the Area (% of total land area) of Burundi and Area (% of total land area) of West Bank and Gaza?
Provide a succinct answer. 7.27. In the year 1997, what is the difference between the Area (% of total land area) of Czech Republic and Area (% of total land area) of West Bank and Gaza?
Your answer should be compact. 32.59. In the year 1998, what is the difference between the Area (% of total land area) of Burkina Faso and Area (% of total land area) of Burundi?
Make the answer very short. 14.86. In the year 1998, what is the difference between the Area (% of total land area) of Burkina Faso and Area (% of total land area) of Czech Republic?
Provide a short and direct response. -10.83. In the year 1998, what is the difference between the Area (% of total land area) of Burkina Faso and Area (% of total land area) of West Bank and Gaza?
Make the answer very short. 21.77. In the year 1998, what is the difference between the Area (% of total land area) in Burundi and Area (% of total land area) in Czech Republic?
Give a very brief answer. -25.69. In the year 1998, what is the difference between the Area (% of total land area) of Burundi and Area (% of total land area) of West Bank and Gaza?
Your answer should be compact. 6.91. In the year 1998, what is the difference between the Area (% of total land area) in Czech Republic and Area (% of total land area) in West Bank and Gaza?
Offer a very short reply. 32.6. In the year 1999, what is the difference between the Area (% of total land area) of Burkina Faso and Area (% of total land area) of Burundi?
Your response must be concise. 14.99. In the year 1999, what is the difference between the Area (% of total land area) of Burkina Faso and Area (% of total land area) of Czech Republic?
Provide a short and direct response. -11.06. In the year 1999, what is the difference between the Area (% of total land area) in Burkina Faso and Area (% of total land area) in West Bank and Gaza?
Your answer should be very brief. 21.55. In the year 1999, what is the difference between the Area (% of total land area) in Burundi and Area (% of total land area) in Czech Republic?
Ensure brevity in your answer.  -26.05. In the year 1999, what is the difference between the Area (% of total land area) in Burundi and Area (% of total land area) in West Bank and Gaza?
Provide a short and direct response. 6.56. In the year 1999, what is the difference between the Area (% of total land area) of Czech Republic and Area (% of total land area) of West Bank and Gaza?
Your answer should be very brief. 32.61. In the year 2000, what is the difference between the Area (% of total land area) in Burkina Faso and Area (% of total land area) in Burundi?
Your answer should be compact. 15.13. In the year 2000, what is the difference between the Area (% of total land area) in Burkina Faso and Area (% of total land area) in Czech Republic?
Keep it short and to the point. -11.29. In the year 2000, what is the difference between the Area (% of total land area) of Burkina Faso and Area (% of total land area) of West Bank and Gaza?
Offer a terse response. 21.33. In the year 2000, what is the difference between the Area (% of total land area) of Burundi and Area (% of total land area) of Czech Republic?
Your response must be concise. -26.42. In the year 2000, what is the difference between the Area (% of total land area) in Burundi and Area (% of total land area) in West Bank and Gaza?
Make the answer very short. 6.2. In the year 2000, what is the difference between the Area (% of total land area) in Czech Republic and Area (% of total land area) in West Bank and Gaza?
Provide a short and direct response. 32.62. In the year 2001, what is the difference between the Area (% of total land area) of Burkina Faso and Area (% of total land area) of Burundi?
Keep it short and to the point. 15.04. In the year 2001, what is the difference between the Area (% of total land area) of Burkina Faso and Area (% of total land area) of Czech Republic?
Make the answer very short. -11.54. In the year 2001, what is the difference between the Area (% of total land area) of Burkina Faso and Area (% of total land area) of West Bank and Gaza?
Give a very brief answer. 21.11. In the year 2001, what is the difference between the Area (% of total land area) in Burundi and Area (% of total land area) in Czech Republic?
Your response must be concise. -26.58. In the year 2001, what is the difference between the Area (% of total land area) of Burundi and Area (% of total land area) of West Bank and Gaza?
Make the answer very short. 6.07. In the year 2001, what is the difference between the Area (% of total land area) of Czech Republic and Area (% of total land area) of West Bank and Gaza?
Your answer should be very brief. 32.64. What is the ratio of the Area (% of total land area) in Burkina Faso in 1995 to that in 1996?
Make the answer very short. 1.01. What is the ratio of the Area (% of total land area) of Burundi in 1995 to that in 1996?
Your response must be concise. 1.04. What is the ratio of the Area (% of total land area) of Czech Republic in 1995 to that in 1996?
Provide a succinct answer. 1. What is the ratio of the Area (% of total land area) in West Bank and Gaza in 1995 to that in 1996?
Offer a terse response. 1. What is the ratio of the Area (% of total land area) of Burkina Faso in 1995 to that in 1997?
Ensure brevity in your answer.  1.02. What is the ratio of the Area (% of total land area) of Burundi in 1995 to that in 1997?
Offer a terse response. 1.08. What is the ratio of the Area (% of total land area) of Burkina Faso in 1995 to that in 1998?
Your answer should be very brief. 1.03. What is the ratio of the Area (% of total land area) in Burundi in 1995 to that in 1998?
Your answer should be compact. 1.13. What is the ratio of the Area (% of total land area) of Czech Republic in 1995 to that in 1998?
Provide a short and direct response. 1. What is the ratio of the Area (% of total land area) of West Bank and Gaza in 1995 to that in 1998?
Provide a succinct answer. 1. What is the ratio of the Area (% of total land area) of Burkina Faso in 1995 to that in 1999?
Your response must be concise. 1.04. What is the ratio of the Area (% of total land area) in Burundi in 1995 to that in 1999?
Give a very brief answer. 1.18. What is the ratio of the Area (% of total land area) of Burkina Faso in 1995 to that in 2000?
Provide a succinct answer. 1.05. What is the ratio of the Area (% of total land area) in Burundi in 1995 to that in 2000?
Keep it short and to the point. 1.23. What is the ratio of the Area (% of total land area) in Czech Republic in 1995 to that in 2000?
Make the answer very short. 1. What is the ratio of the Area (% of total land area) in West Bank and Gaza in 1995 to that in 2000?
Your response must be concise. 1. What is the ratio of the Area (% of total land area) in Burkina Faso in 1995 to that in 2001?
Offer a terse response. 1.06. What is the ratio of the Area (% of total land area) in Burundi in 1995 to that in 2001?
Keep it short and to the point. 1.25. What is the ratio of the Area (% of total land area) in Burkina Faso in 1996 to that in 1997?
Offer a very short reply. 1.01. What is the ratio of the Area (% of total land area) in Burundi in 1996 to that in 1997?
Provide a short and direct response. 1.04. What is the ratio of the Area (% of total land area) of Czech Republic in 1996 to that in 1997?
Keep it short and to the point. 1. What is the ratio of the Area (% of total land area) in Burkina Faso in 1996 to that in 1998?
Ensure brevity in your answer.  1.02. What is the ratio of the Area (% of total land area) of Burundi in 1996 to that in 1998?
Your answer should be compact. 1.08. What is the ratio of the Area (% of total land area) of Czech Republic in 1996 to that in 1998?
Make the answer very short. 1. What is the ratio of the Area (% of total land area) in West Bank and Gaza in 1996 to that in 1998?
Give a very brief answer. 1. What is the ratio of the Area (% of total land area) of Burkina Faso in 1996 to that in 1999?
Offer a very short reply. 1.03. What is the ratio of the Area (% of total land area) in Burundi in 1996 to that in 1999?
Your answer should be very brief. 1.13. What is the ratio of the Area (% of total land area) of Czech Republic in 1996 to that in 1999?
Your answer should be compact. 1. What is the ratio of the Area (% of total land area) in West Bank and Gaza in 1996 to that in 1999?
Ensure brevity in your answer.  1. What is the ratio of the Area (% of total land area) in Burkina Faso in 1996 to that in 2000?
Keep it short and to the point. 1.04. What is the ratio of the Area (% of total land area) in Burundi in 1996 to that in 2000?
Ensure brevity in your answer.  1.18. What is the ratio of the Area (% of total land area) in West Bank and Gaza in 1996 to that in 2000?
Keep it short and to the point. 1. What is the ratio of the Area (% of total land area) of Burkina Faso in 1996 to that in 2001?
Your answer should be very brief. 1.05. What is the ratio of the Area (% of total land area) in Burundi in 1996 to that in 2001?
Provide a succinct answer. 1.2. What is the ratio of the Area (% of total land area) of Czech Republic in 1996 to that in 2001?
Ensure brevity in your answer.  1. What is the ratio of the Area (% of total land area) of Burkina Faso in 1997 to that in 1998?
Give a very brief answer. 1.01. What is the ratio of the Area (% of total land area) in Burundi in 1997 to that in 1998?
Your answer should be compact. 1.04. What is the ratio of the Area (% of total land area) of Czech Republic in 1997 to that in 1998?
Offer a terse response. 1. What is the ratio of the Area (% of total land area) of West Bank and Gaza in 1997 to that in 1998?
Offer a terse response. 1. What is the ratio of the Area (% of total land area) of Burundi in 1997 to that in 1999?
Offer a terse response. 1.09. What is the ratio of the Area (% of total land area) in Czech Republic in 1997 to that in 1999?
Ensure brevity in your answer.  1. What is the ratio of the Area (% of total land area) in Burkina Faso in 1997 to that in 2000?
Provide a succinct answer. 1.03. What is the ratio of the Area (% of total land area) in Burundi in 1997 to that in 2000?
Provide a succinct answer. 1.14. What is the ratio of the Area (% of total land area) in Czech Republic in 1997 to that in 2000?
Your response must be concise. 1. What is the ratio of the Area (% of total land area) of Burkina Faso in 1997 to that in 2001?
Give a very brief answer. 1.04. What is the ratio of the Area (% of total land area) of Burundi in 1997 to that in 2001?
Provide a short and direct response. 1.16. What is the ratio of the Area (% of total land area) of Czech Republic in 1997 to that in 2001?
Provide a succinct answer. 1. What is the ratio of the Area (% of total land area) in Burkina Faso in 1998 to that in 1999?
Provide a succinct answer. 1.01. What is the ratio of the Area (% of total land area) of Burundi in 1998 to that in 1999?
Provide a short and direct response. 1.04. What is the ratio of the Area (% of total land area) of Czech Republic in 1998 to that in 1999?
Offer a very short reply. 1. What is the ratio of the Area (% of total land area) in West Bank and Gaza in 1998 to that in 1999?
Your response must be concise. 1. What is the ratio of the Area (% of total land area) in Burkina Faso in 1998 to that in 2000?
Your answer should be compact. 1.02. What is the ratio of the Area (% of total land area) of Burundi in 1998 to that in 2000?
Offer a very short reply. 1.09. What is the ratio of the Area (% of total land area) of Burkina Faso in 1998 to that in 2001?
Make the answer very short. 1.03. What is the ratio of the Area (% of total land area) of Burundi in 1998 to that in 2001?
Offer a terse response. 1.11. What is the ratio of the Area (% of total land area) in Czech Republic in 1998 to that in 2001?
Provide a short and direct response. 1. What is the ratio of the Area (% of total land area) in West Bank and Gaza in 1998 to that in 2001?
Provide a short and direct response. 1. What is the ratio of the Area (% of total land area) of Burkina Faso in 1999 to that in 2000?
Your response must be concise. 1.01. What is the ratio of the Area (% of total land area) in Burundi in 1999 to that in 2000?
Provide a short and direct response. 1.05. What is the ratio of the Area (% of total land area) of Burkina Faso in 1999 to that in 2001?
Give a very brief answer. 1.02. What is the ratio of the Area (% of total land area) of Burundi in 1999 to that in 2001?
Keep it short and to the point. 1.06. What is the ratio of the Area (% of total land area) in Burkina Faso in 2000 to that in 2001?
Your answer should be very brief. 1.01. What is the ratio of the Area (% of total land area) of Burundi in 2000 to that in 2001?
Your answer should be very brief. 1.02. What is the ratio of the Area (% of total land area) in Czech Republic in 2000 to that in 2001?
Ensure brevity in your answer.  1. What is the ratio of the Area (% of total land area) in West Bank and Gaza in 2000 to that in 2001?
Offer a terse response. 1. What is the difference between the highest and the second highest Area (% of total land area) of Burkina Faso?
Provide a succinct answer. 0.22. What is the difference between the highest and the second highest Area (% of total land area) in Burundi?
Your answer should be compact. 0.35. What is the difference between the highest and the second highest Area (% of total land area) of Czech Republic?
Offer a terse response. 0.03. What is the difference between the highest and the second highest Area (% of total land area) of West Bank and Gaza?
Offer a very short reply. 0. What is the difference between the highest and the lowest Area (% of total land area) in Burkina Faso?
Give a very brief answer. 1.31. What is the difference between the highest and the lowest Area (% of total land area) in Burundi?
Give a very brief answer. 1.9. What is the difference between the highest and the lowest Area (% of total land area) in Czech Republic?
Ensure brevity in your answer.  0.08. What is the difference between the highest and the lowest Area (% of total land area) of West Bank and Gaza?
Offer a terse response. 0. 